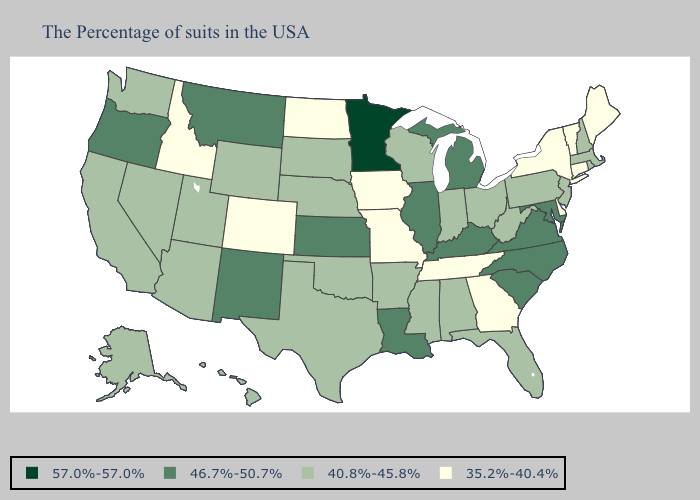Does Massachusetts have a higher value than Colorado?
Give a very brief answer. Yes. What is the highest value in states that border Kansas?
Short answer required. 40.8%-45.8%. Name the states that have a value in the range 46.7%-50.7%?
Short answer required. Maryland, Virginia, North Carolina, South Carolina, Michigan, Kentucky, Illinois, Louisiana, Kansas, New Mexico, Montana, Oregon. What is the value of South Dakota?
Give a very brief answer. 40.8%-45.8%. Name the states that have a value in the range 57.0%-57.0%?
Answer briefly. Minnesota. What is the lowest value in the MidWest?
Answer briefly. 35.2%-40.4%. What is the highest value in the USA?
Keep it brief. 57.0%-57.0%. What is the lowest value in states that border Nevada?
Keep it brief. 35.2%-40.4%. Which states have the highest value in the USA?
Short answer required. Minnesota. What is the lowest value in states that border Rhode Island?
Short answer required. 35.2%-40.4%. Which states have the lowest value in the USA?
Keep it brief. Maine, Vermont, Connecticut, New York, Delaware, Georgia, Tennessee, Missouri, Iowa, North Dakota, Colorado, Idaho. What is the value of Connecticut?
Keep it brief. 35.2%-40.4%. What is the highest value in the West ?
Give a very brief answer. 46.7%-50.7%. What is the lowest value in the West?
Be succinct. 35.2%-40.4%. Name the states that have a value in the range 57.0%-57.0%?
Concise answer only. Minnesota. 